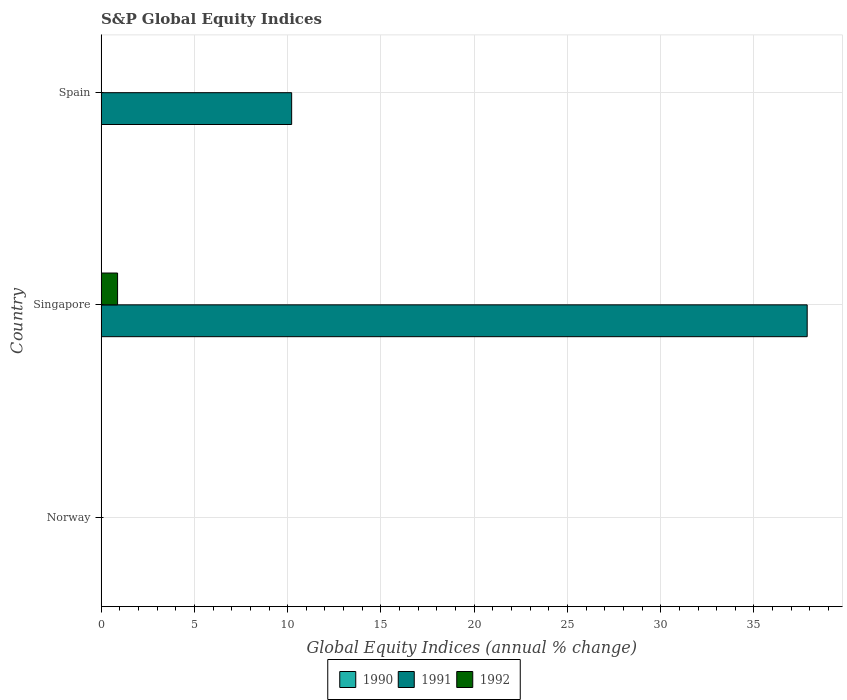How many different coloured bars are there?
Provide a short and direct response. 2. Are the number of bars per tick equal to the number of legend labels?
Your answer should be compact. No. What is the label of the 2nd group of bars from the top?
Provide a short and direct response. Singapore. What is the global equity indices in 1992 in Norway?
Your answer should be very brief. 0. Across all countries, what is the maximum global equity indices in 1992?
Offer a terse response. 0.88. In which country was the global equity indices in 1992 maximum?
Make the answer very short. Singapore. What is the total global equity indices in 1991 in the graph?
Give a very brief answer. 48.07. What is the difference between the global equity indices in 1991 in Singapore and that in Spain?
Offer a terse response. 27.64. What is the difference between the global equity indices in 1990 in Spain and the global equity indices in 1992 in Singapore?
Your answer should be very brief. -0.88. What is the average global equity indices in 1991 per country?
Your answer should be compact. 16.02. What is the difference between the global equity indices in 1992 and global equity indices in 1991 in Singapore?
Make the answer very short. -36.97. What is the ratio of the global equity indices in 1991 in Singapore to that in Spain?
Offer a terse response. 3.71. Is the global equity indices in 1991 in Singapore less than that in Spain?
Make the answer very short. No. What is the difference between the highest and the lowest global equity indices in 1991?
Give a very brief answer. 37.85. In how many countries, is the global equity indices in 1990 greater than the average global equity indices in 1990 taken over all countries?
Offer a very short reply. 0. Does the graph contain any zero values?
Make the answer very short. Yes. Does the graph contain grids?
Keep it short and to the point. Yes. What is the title of the graph?
Keep it short and to the point. S&P Global Equity Indices. What is the label or title of the X-axis?
Your answer should be very brief. Global Equity Indices (annual % change). What is the Global Equity Indices (annual % change) of 1990 in Norway?
Provide a succinct answer. 0. What is the Global Equity Indices (annual % change) in 1991 in Singapore?
Give a very brief answer. 37.85. What is the Global Equity Indices (annual % change) in 1992 in Singapore?
Ensure brevity in your answer.  0.88. What is the Global Equity Indices (annual % change) of 1991 in Spain?
Offer a very short reply. 10.21. Across all countries, what is the maximum Global Equity Indices (annual % change) of 1991?
Ensure brevity in your answer.  37.85. Across all countries, what is the maximum Global Equity Indices (annual % change) of 1992?
Offer a very short reply. 0.88. What is the total Global Equity Indices (annual % change) of 1990 in the graph?
Keep it short and to the point. 0. What is the total Global Equity Indices (annual % change) of 1991 in the graph?
Your answer should be compact. 48.07. What is the total Global Equity Indices (annual % change) of 1992 in the graph?
Your response must be concise. 0.88. What is the difference between the Global Equity Indices (annual % change) of 1991 in Singapore and that in Spain?
Your answer should be compact. 27.64. What is the average Global Equity Indices (annual % change) of 1991 per country?
Provide a succinct answer. 16.02. What is the average Global Equity Indices (annual % change) of 1992 per country?
Ensure brevity in your answer.  0.29. What is the difference between the Global Equity Indices (annual % change) of 1991 and Global Equity Indices (annual % change) of 1992 in Singapore?
Offer a very short reply. 36.97. What is the ratio of the Global Equity Indices (annual % change) of 1991 in Singapore to that in Spain?
Offer a very short reply. 3.71. What is the difference between the highest and the lowest Global Equity Indices (annual % change) in 1991?
Your response must be concise. 37.85. What is the difference between the highest and the lowest Global Equity Indices (annual % change) in 1992?
Your answer should be very brief. 0.88. 